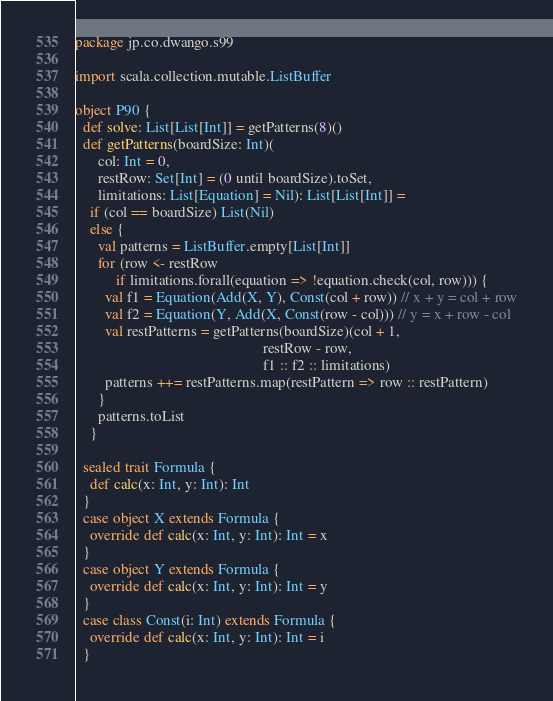<code> <loc_0><loc_0><loc_500><loc_500><_Scala_>package jp.co.dwango.s99

import scala.collection.mutable.ListBuffer

object P90 {
  def solve: List[List[Int]] = getPatterns(8)()
  def getPatterns(boardSize: Int)(
      col: Int = 0,
      restRow: Set[Int] = (0 until boardSize).toSet,
      limitations: List[Equation] = Nil): List[List[Int]] =
    if (col == boardSize) List(Nil)
    else {
      val patterns = ListBuffer.empty[List[Int]]
      for (row <- restRow
           if limitations.forall(equation => !equation.check(col, row))) {
        val f1 = Equation(Add(X, Y), Const(col + row)) // x + y = col + row
        val f2 = Equation(Y, Add(X, Const(row - col))) // y = x + row - col
        val restPatterns = getPatterns(boardSize)(col + 1,
                                                  restRow - row,
                                                  f1 :: f2 :: limitations)
        patterns ++= restPatterns.map(restPattern => row :: restPattern)
      }
      patterns.toList
    }

  sealed trait Formula {
    def calc(x: Int, y: Int): Int
  }
  case object X extends Formula {
    override def calc(x: Int, y: Int): Int = x
  }
  case object Y extends Formula {
    override def calc(x: Int, y: Int): Int = y
  }
  case class Const(i: Int) extends Formula {
    override def calc(x: Int, y: Int): Int = i
  }</code> 